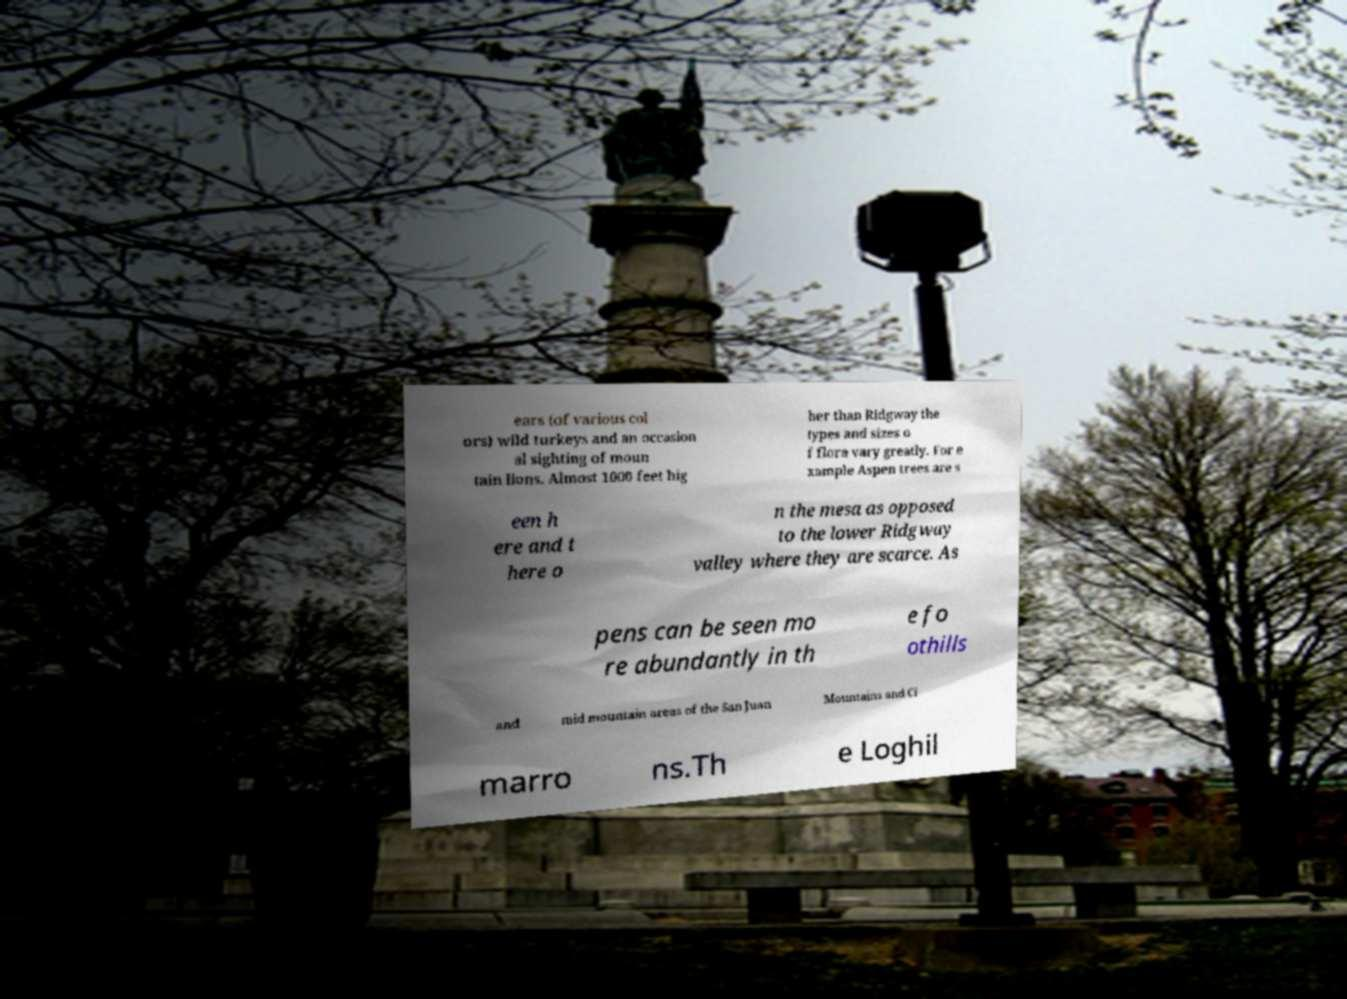Could you extract and type out the text from this image? ears (of various col ors) wild turkeys and an occasion al sighting of moun tain lions. Almost 1000 feet hig her than Ridgway the types and sizes o f flora vary greatly. For e xample Aspen trees are s een h ere and t here o n the mesa as opposed to the lower Ridgway valley where they are scarce. As pens can be seen mo re abundantly in th e fo othills and mid mountain areas of the San Juan Mountains and Ci marro ns.Th e Loghil 